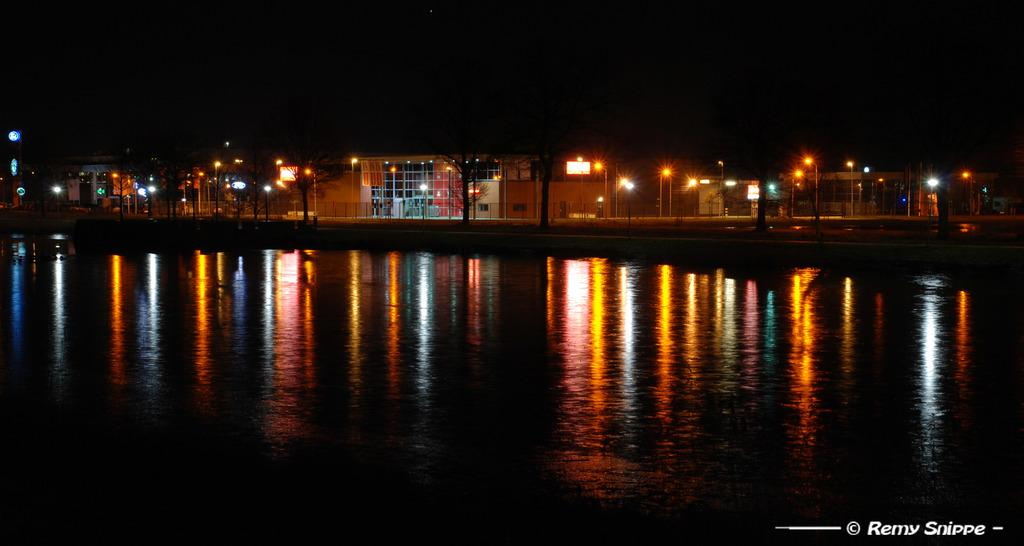What is the lighting condition in the image? The image was taken in the dark. What can be seen at the bottom of the image? There is water visible at the bottom of the image. What is visible in the background of the image? There are many buildings and light poles in the background of the image. How would you describe the overall lighting in the background? The background is dark. What type of sugar can be seen on the smile of the person in the image? There is no person or smile present in the image, so there is no sugar visible. 